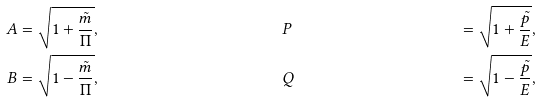<formula> <loc_0><loc_0><loc_500><loc_500>A & = \sqrt { 1 + \frac { \tilde { m } } { \Pi } } , & \quad & P & = \sqrt { 1 + \frac { \tilde { p } } { E } } , \\ B & = \sqrt { 1 - \frac { \tilde { m } } { \Pi } } , & \quad & Q & = \sqrt { 1 - \frac { \tilde { p } } { E } } , \\</formula> 